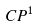Convert formula to latex. <formula><loc_0><loc_0><loc_500><loc_500>C P ^ { 1 }</formula> 